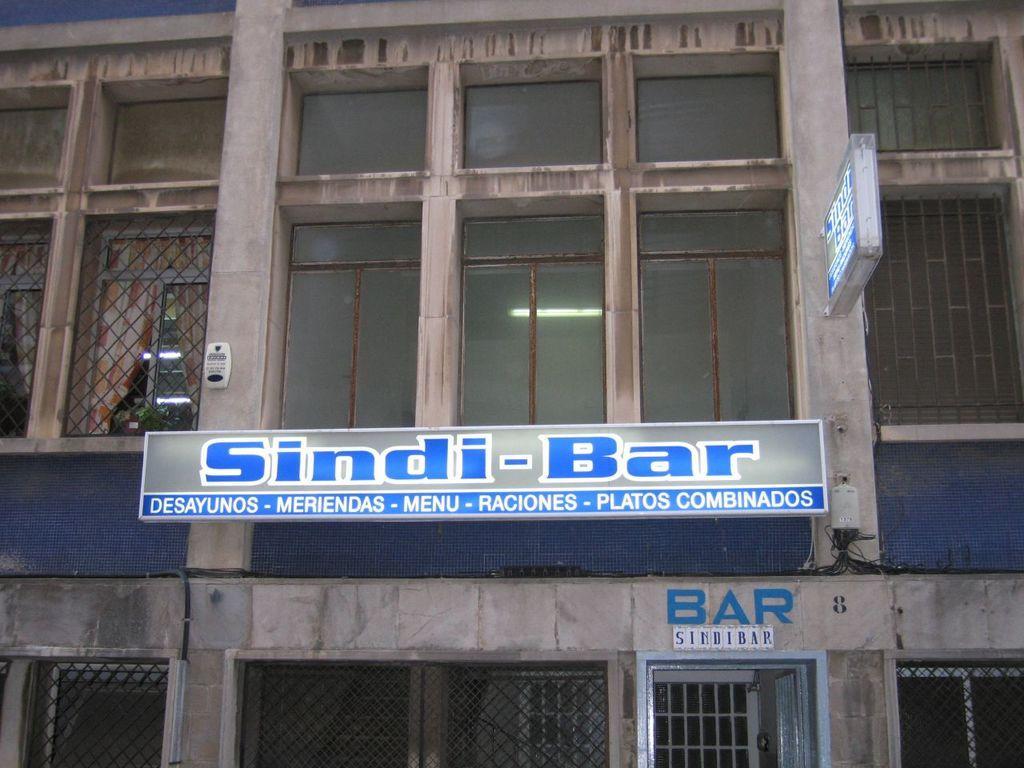In one or two sentences, can you explain what this image depicts? In this image there is a building, for that building there are windows and doors. 